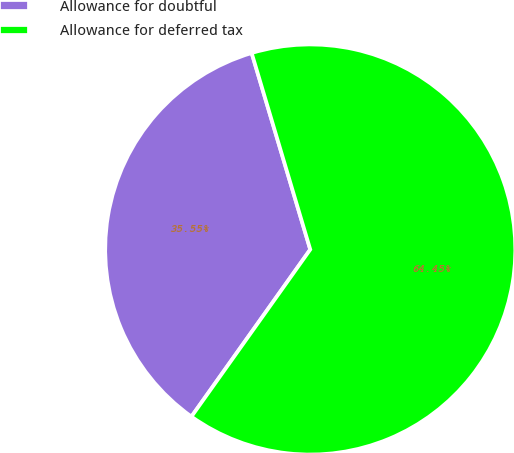<chart> <loc_0><loc_0><loc_500><loc_500><pie_chart><fcel>Allowance for doubtful<fcel>Allowance for deferred tax<nl><fcel>35.55%<fcel>64.45%<nl></chart> 